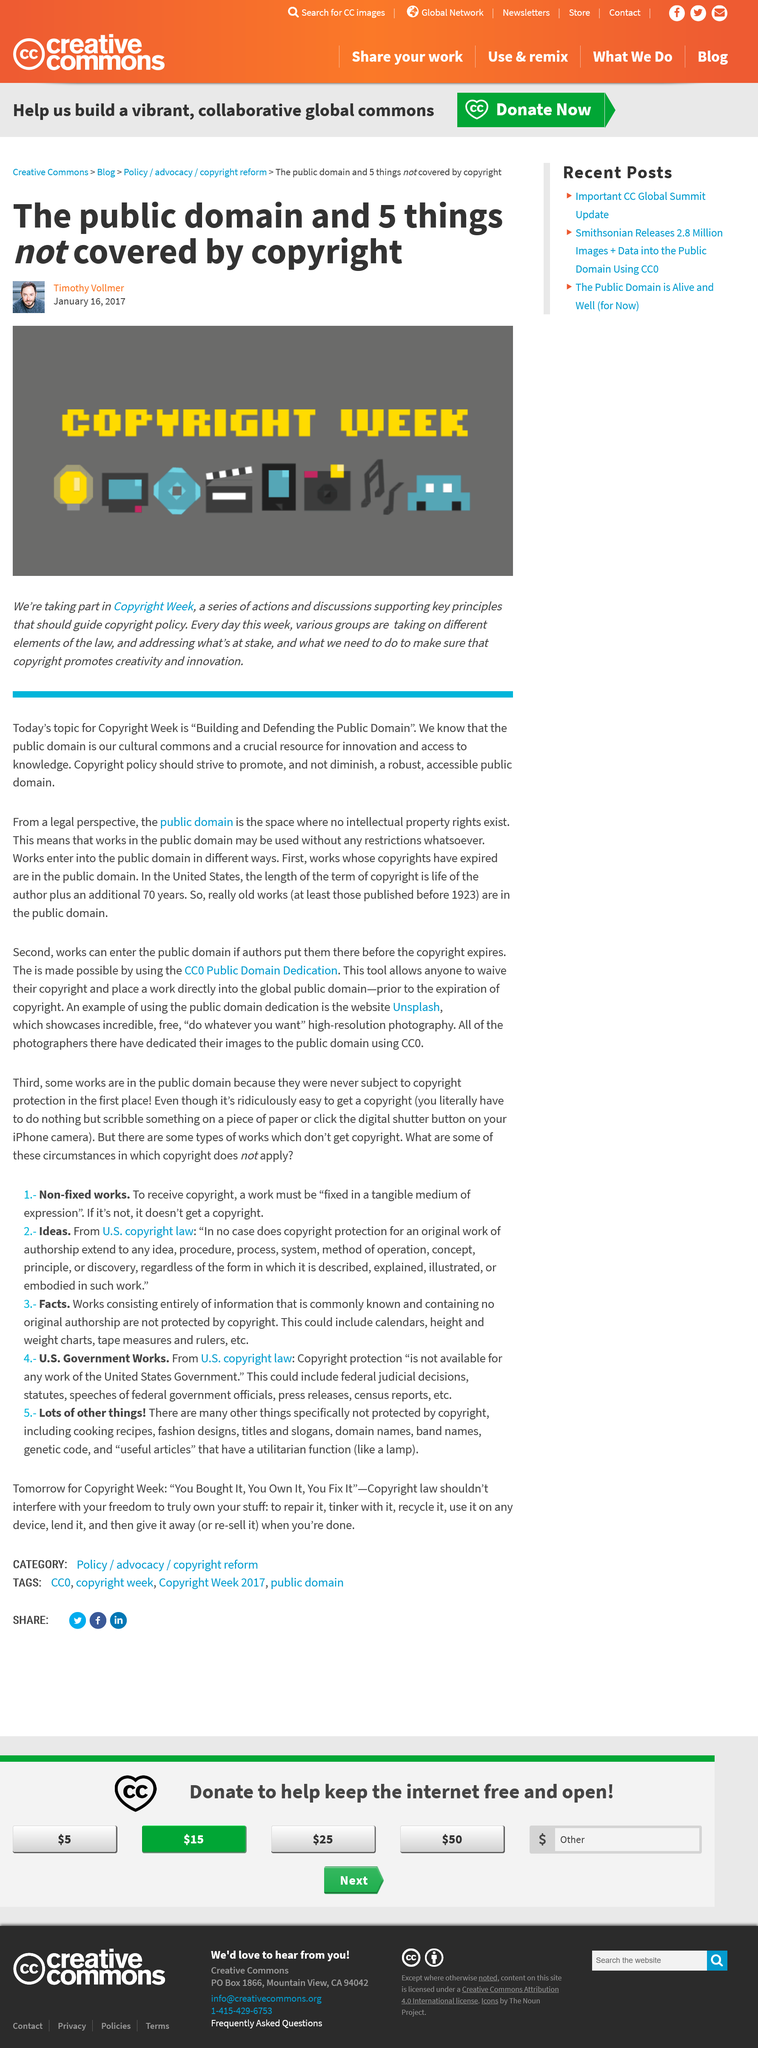Specify some key components in this picture. On January 16th, 2017, Timothy Vollmer created this article. The title of this article is 'What is the title of this article? The public domain and 5 things not covered by copyright..' Copyright Week is the week designated to raise awareness and promote education on the importance of copyright laws and their impact on the creative community. 